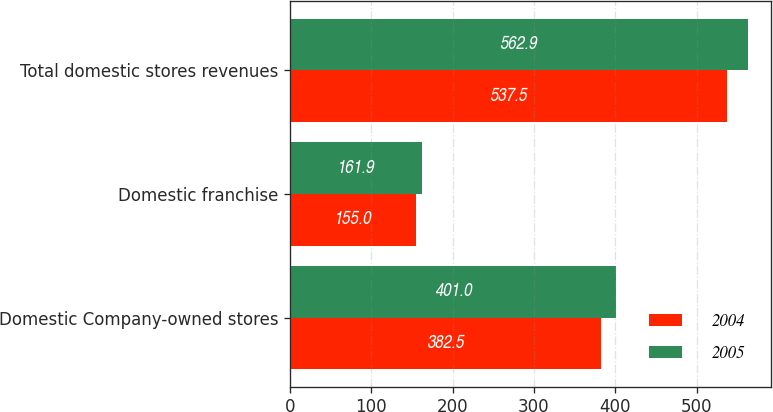<chart> <loc_0><loc_0><loc_500><loc_500><stacked_bar_chart><ecel><fcel>Domestic Company-owned stores<fcel>Domestic franchise<fcel>Total domestic stores revenues<nl><fcel>2004<fcel>382.5<fcel>155<fcel>537.5<nl><fcel>2005<fcel>401<fcel>161.9<fcel>562.9<nl></chart> 